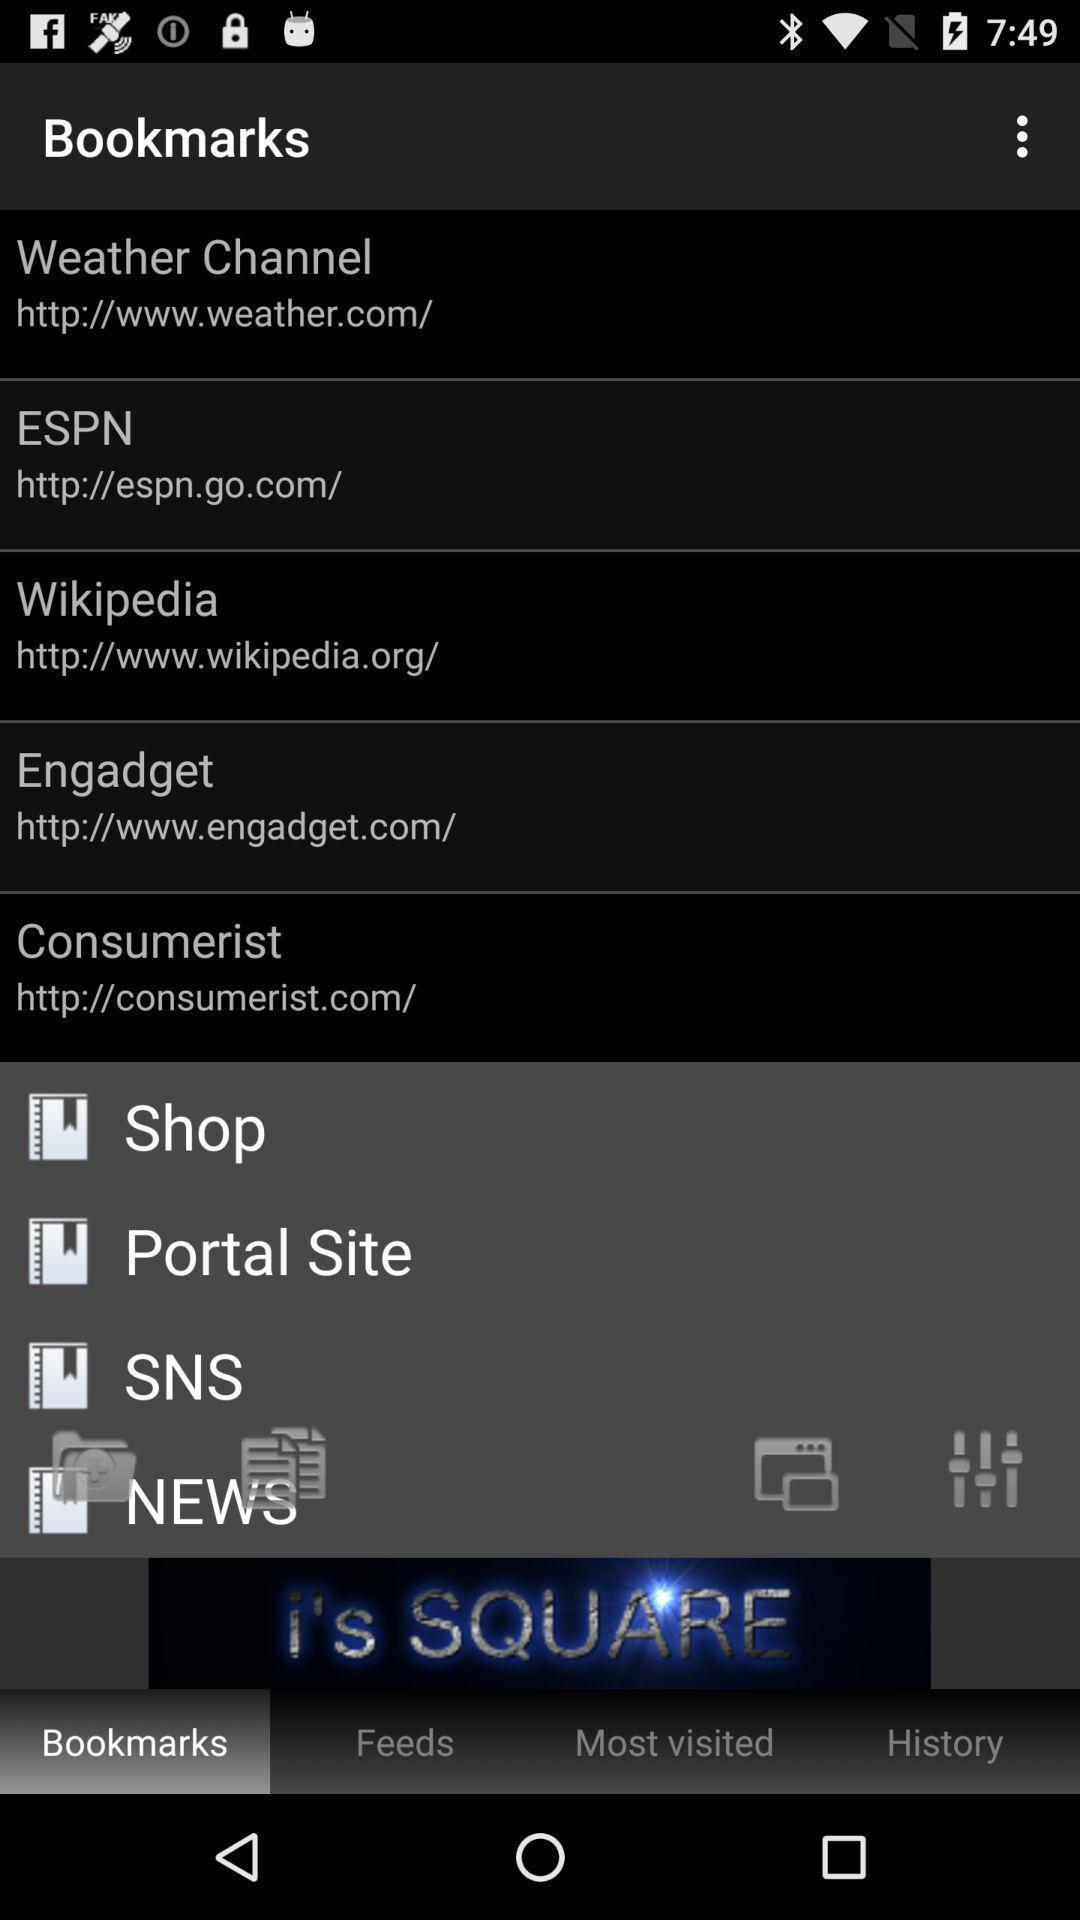Which tab has been selected? The selected tab is "Bookmarks". 